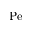Convert formula to latex. <formula><loc_0><loc_0><loc_500><loc_500>P e</formula> 